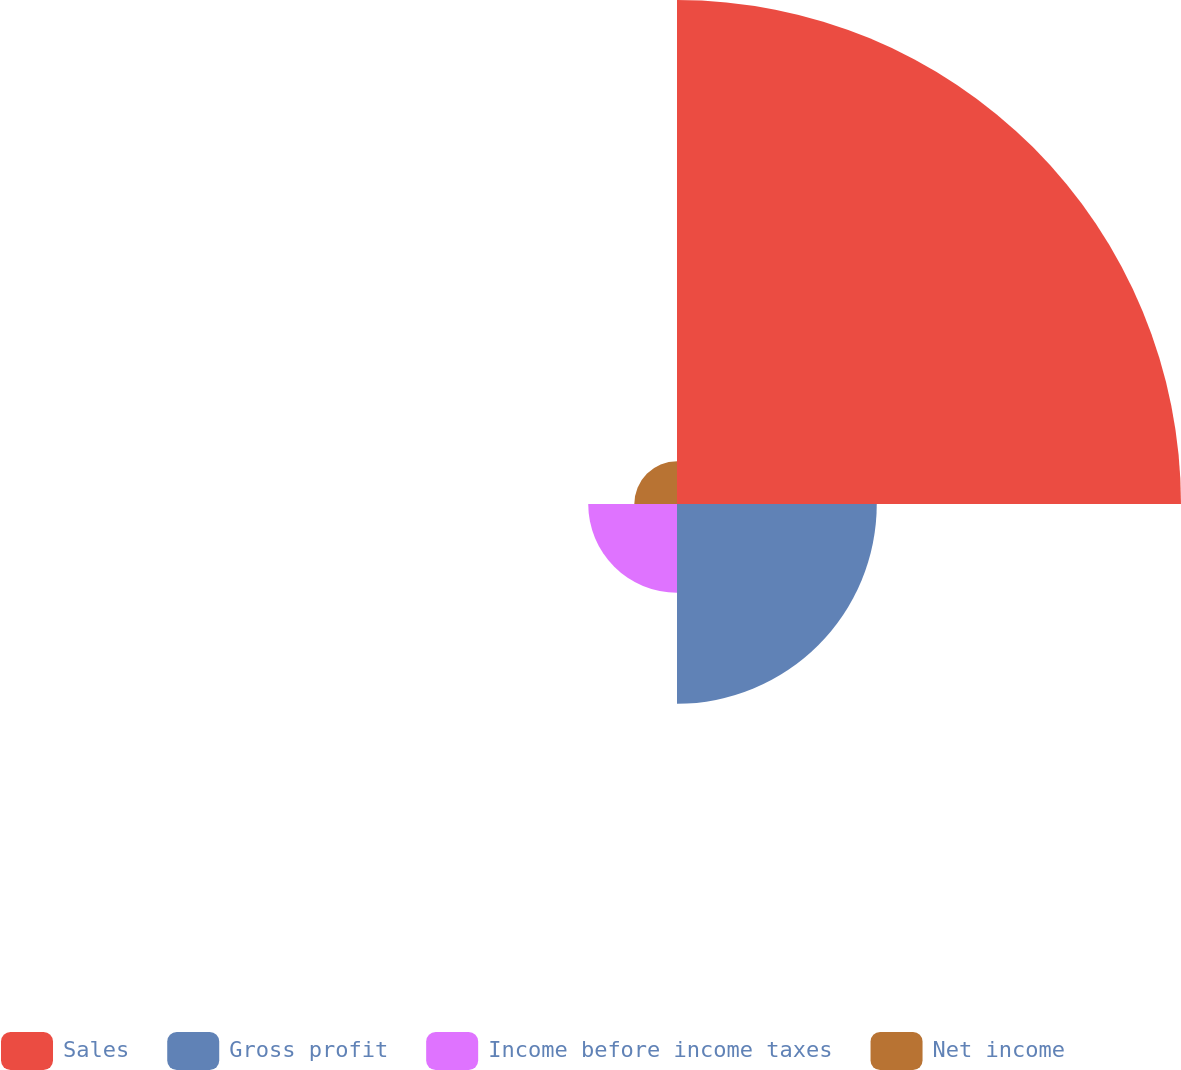Convert chart. <chart><loc_0><loc_0><loc_500><loc_500><pie_chart><fcel>Sales<fcel>Gross profit<fcel>Income before income taxes<fcel>Net income<nl><fcel>60.35%<fcel>23.92%<fcel>10.63%<fcel>5.11%<nl></chart> 